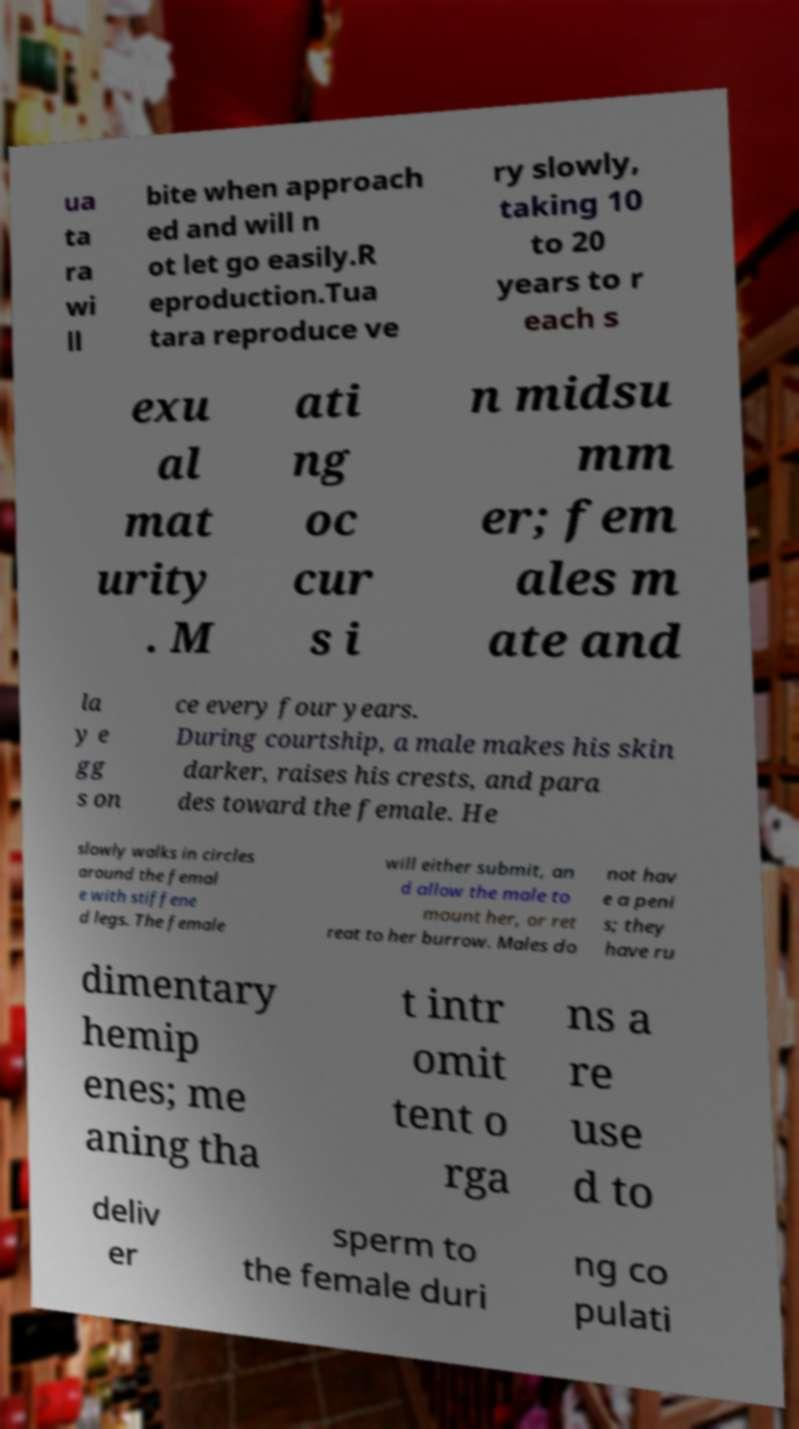Could you extract and type out the text from this image? ua ta ra wi ll bite when approach ed and will n ot let go easily.R eproduction.Tua tara reproduce ve ry slowly, taking 10 to 20 years to r each s exu al mat urity . M ati ng oc cur s i n midsu mm er; fem ales m ate and la y e gg s on ce every four years. During courtship, a male makes his skin darker, raises his crests, and para des toward the female. He slowly walks in circles around the femal e with stiffene d legs. The female will either submit, an d allow the male to mount her, or ret reat to her burrow. Males do not hav e a peni s; they have ru dimentary hemip enes; me aning tha t intr omit tent o rga ns a re use d to deliv er sperm to the female duri ng co pulati 